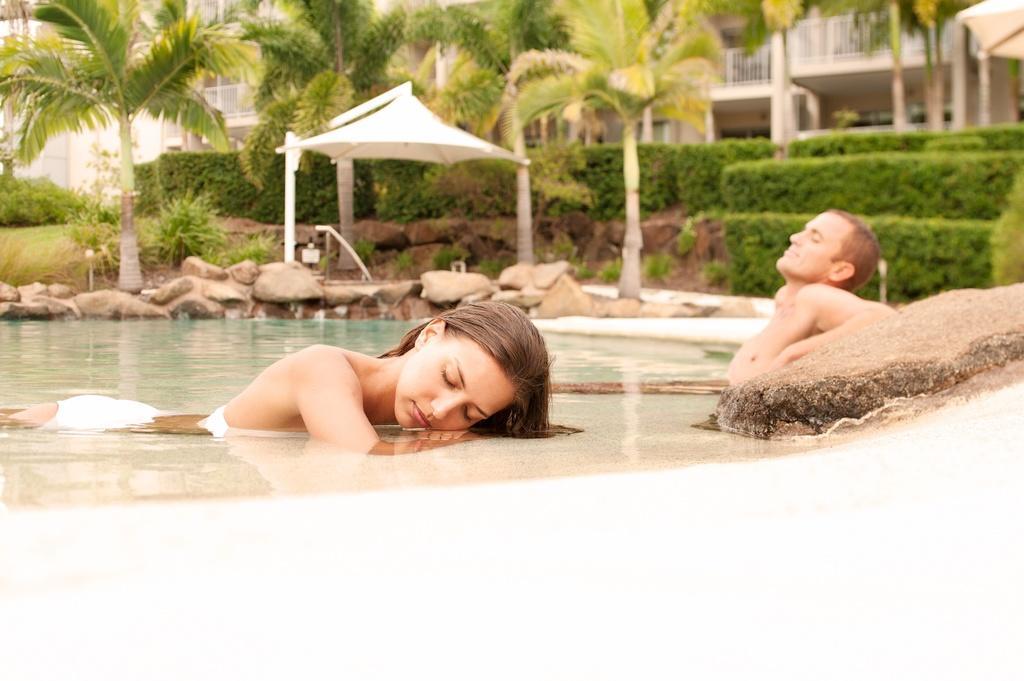How would you summarize this image in a sentence or two? This picture is clicked outside. In the center we can see a woman and a man in the water body and we can see the rocks. In the background we can see the plants, green grass, shrubs, tent, trees and buildings. 